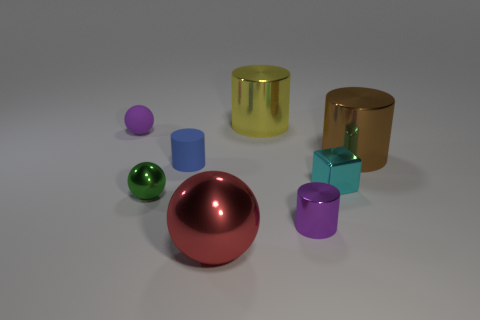The purple thing behind the purple object in front of the small cylinder that is left of the small purple metal cylinder is made of what material?
Make the answer very short. Rubber. Does the tiny ball behind the large brown shiny object have the same material as the small blue thing?
Your answer should be compact. Yes. What number of metal objects are the same size as the purple cylinder?
Ensure brevity in your answer.  2. Is the number of small green metal spheres in front of the matte cylinder greater than the number of brown metallic things that are to the right of the brown cylinder?
Keep it short and to the point. Yes. Are there any large brown rubber things that have the same shape as the red metal thing?
Provide a succinct answer. No. How big is the metallic ball on the left side of the matte thing that is on the right side of the small green shiny sphere?
Offer a terse response. Small. What shape is the small cyan metallic thing on the right side of the tiny metal cylinder in front of the rubber object that is on the left side of the green object?
Your response must be concise. Cube. What is the size of the brown object that is the same material as the yellow cylinder?
Provide a succinct answer. Large. Is the number of green metal spheres greater than the number of metal cylinders?
Your answer should be very brief. No. What is the material of the red ball that is the same size as the yellow metal thing?
Offer a very short reply. Metal. 